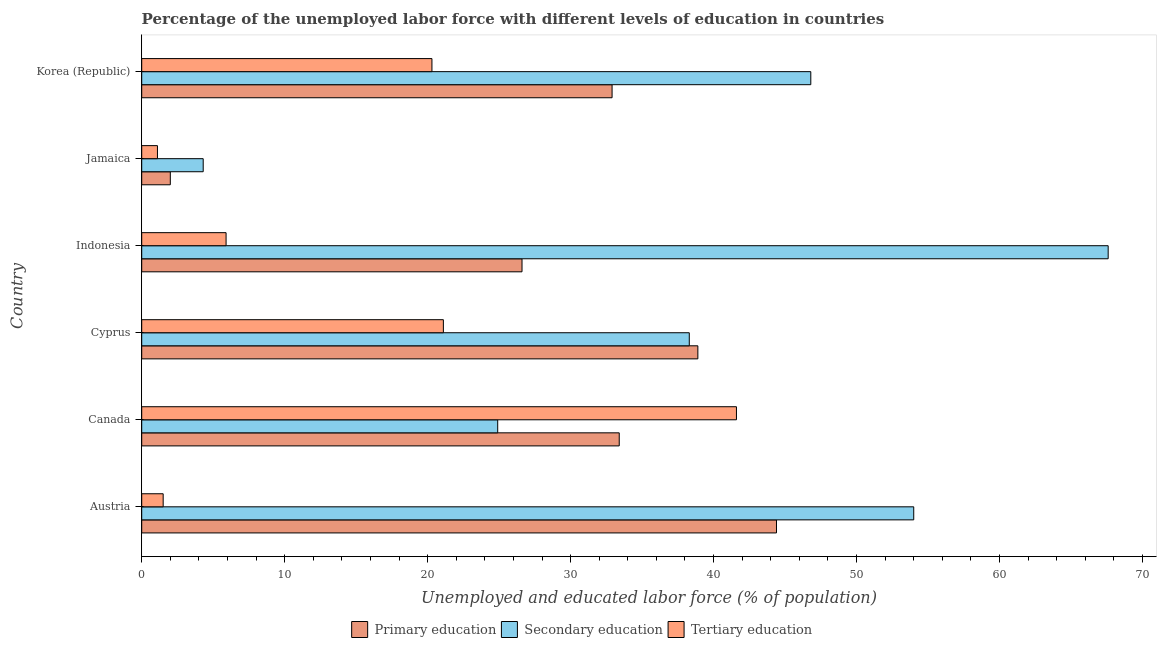How many groups of bars are there?
Your answer should be compact. 6. How many bars are there on the 1st tick from the bottom?
Provide a short and direct response. 3. What is the label of the 3rd group of bars from the top?
Provide a short and direct response. Indonesia. What is the percentage of labor force who received primary education in Indonesia?
Offer a very short reply. 26.6. Across all countries, what is the maximum percentage of labor force who received primary education?
Offer a terse response. 44.4. Across all countries, what is the minimum percentage of labor force who received secondary education?
Your answer should be very brief. 4.3. In which country was the percentage of labor force who received tertiary education maximum?
Offer a terse response. Canada. In which country was the percentage of labor force who received primary education minimum?
Provide a succinct answer. Jamaica. What is the total percentage of labor force who received tertiary education in the graph?
Provide a short and direct response. 91.5. What is the difference between the percentage of labor force who received primary education in Canada and the percentage of labor force who received tertiary education in Korea (Republic)?
Provide a short and direct response. 13.1. What is the average percentage of labor force who received secondary education per country?
Provide a short and direct response. 39.32. What is the difference between the percentage of labor force who received tertiary education and percentage of labor force who received primary education in Canada?
Provide a short and direct response. 8.2. What is the ratio of the percentage of labor force who received primary education in Austria to that in Canada?
Your answer should be very brief. 1.33. Is the difference between the percentage of labor force who received primary education in Indonesia and Korea (Republic) greater than the difference between the percentage of labor force who received tertiary education in Indonesia and Korea (Republic)?
Your answer should be compact. Yes. What is the difference between the highest and the second highest percentage of labor force who received tertiary education?
Your answer should be very brief. 20.5. What is the difference between the highest and the lowest percentage of labor force who received secondary education?
Offer a very short reply. 63.3. In how many countries, is the percentage of labor force who received secondary education greater than the average percentage of labor force who received secondary education taken over all countries?
Offer a very short reply. 3. What does the 1st bar from the bottom in Cyprus represents?
Your response must be concise. Primary education. Is it the case that in every country, the sum of the percentage of labor force who received primary education and percentage of labor force who received secondary education is greater than the percentage of labor force who received tertiary education?
Your answer should be compact. Yes. How many bars are there?
Your answer should be very brief. 18. What is the difference between two consecutive major ticks on the X-axis?
Provide a short and direct response. 10. Does the graph contain any zero values?
Offer a terse response. No. What is the title of the graph?
Offer a very short reply. Percentage of the unemployed labor force with different levels of education in countries. What is the label or title of the X-axis?
Provide a succinct answer. Unemployed and educated labor force (% of population). What is the label or title of the Y-axis?
Your answer should be compact. Country. What is the Unemployed and educated labor force (% of population) of Primary education in Austria?
Provide a short and direct response. 44.4. What is the Unemployed and educated labor force (% of population) in Secondary education in Austria?
Offer a very short reply. 54. What is the Unemployed and educated labor force (% of population) of Primary education in Canada?
Give a very brief answer. 33.4. What is the Unemployed and educated labor force (% of population) of Secondary education in Canada?
Your answer should be compact. 24.9. What is the Unemployed and educated labor force (% of population) in Tertiary education in Canada?
Keep it short and to the point. 41.6. What is the Unemployed and educated labor force (% of population) in Primary education in Cyprus?
Give a very brief answer. 38.9. What is the Unemployed and educated labor force (% of population) of Secondary education in Cyprus?
Make the answer very short. 38.3. What is the Unemployed and educated labor force (% of population) in Tertiary education in Cyprus?
Offer a very short reply. 21.1. What is the Unemployed and educated labor force (% of population) in Primary education in Indonesia?
Keep it short and to the point. 26.6. What is the Unemployed and educated labor force (% of population) of Secondary education in Indonesia?
Offer a terse response. 67.6. What is the Unemployed and educated labor force (% of population) of Tertiary education in Indonesia?
Make the answer very short. 5.9. What is the Unemployed and educated labor force (% of population) of Primary education in Jamaica?
Make the answer very short. 2. What is the Unemployed and educated labor force (% of population) of Secondary education in Jamaica?
Offer a terse response. 4.3. What is the Unemployed and educated labor force (% of population) of Tertiary education in Jamaica?
Your response must be concise. 1.1. What is the Unemployed and educated labor force (% of population) in Primary education in Korea (Republic)?
Offer a terse response. 32.9. What is the Unemployed and educated labor force (% of population) of Secondary education in Korea (Republic)?
Your answer should be compact. 46.8. What is the Unemployed and educated labor force (% of population) in Tertiary education in Korea (Republic)?
Your response must be concise. 20.3. Across all countries, what is the maximum Unemployed and educated labor force (% of population) of Primary education?
Offer a very short reply. 44.4. Across all countries, what is the maximum Unemployed and educated labor force (% of population) in Secondary education?
Provide a short and direct response. 67.6. Across all countries, what is the maximum Unemployed and educated labor force (% of population) in Tertiary education?
Your response must be concise. 41.6. Across all countries, what is the minimum Unemployed and educated labor force (% of population) of Secondary education?
Your response must be concise. 4.3. Across all countries, what is the minimum Unemployed and educated labor force (% of population) in Tertiary education?
Offer a very short reply. 1.1. What is the total Unemployed and educated labor force (% of population) in Primary education in the graph?
Make the answer very short. 178.2. What is the total Unemployed and educated labor force (% of population) in Secondary education in the graph?
Offer a very short reply. 235.9. What is the total Unemployed and educated labor force (% of population) in Tertiary education in the graph?
Make the answer very short. 91.5. What is the difference between the Unemployed and educated labor force (% of population) in Primary education in Austria and that in Canada?
Give a very brief answer. 11. What is the difference between the Unemployed and educated labor force (% of population) in Secondary education in Austria and that in Canada?
Offer a very short reply. 29.1. What is the difference between the Unemployed and educated labor force (% of population) of Tertiary education in Austria and that in Canada?
Your response must be concise. -40.1. What is the difference between the Unemployed and educated labor force (% of population) of Primary education in Austria and that in Cyprus?
Your answer should be compact. 5.5. What is the difference between the Unemployed and educated labor force (% of population) of Secondary education in Austria and that in Cyprus?
Provide a short and direct response. 15.7. What is the difference between the Unemployed and educated labor force (% of population) of Tertiary education in Austria and that in Cyprus?
Provide a succinct answer. -19.6. What is the difference between the Unemployed and educated labor force (% of population) in Primary education in Austria and that in Indonesia?
Offer a terse response. 17.8. What is the difference between the Unemployed and educated labor force (% of population) in Primary education in Austria and that in Jamaica?
Provide a short and direct response. 42.4. What is the difference between the Unemployed and educated labor force (% of population) of Secondary education in Austria and that in Jamaica?
Ensure brevity in your answer.  49.7. What is the difference between the Unemployed and educated labor force (% of population) in Primary education in Austria and that in Korea (Republic)?
Provide a short and direct response. 11.5. What is the difference between the Unemployed and educated labor force (% of population) of Tertiary education in Austria and that in Korea (Republic)?
Your answer should be compact. -18.8. What is the difference between the Unemployed and educated labor force (% of population) in Primary education in Canada and that in Cyprus?
Provide a short and direct response. -5.5. What is the difference between the Unemployed and educated labor force (% of population) of Secondary education in Canada and that in Cyprus?
Your answer should be very brief. -13.4. What is the difference between the Unemployed and educated labor force (% of population) of Tertiary education in Canada and that in Cyprus?
Provide a succinct answer. 20.5. What is the difference between the Unemployed and educated labor force (% of population) in Primary education in Canada and that in Indonesia?
Give a very brief answer. 6.8. What is the difference between the Unemployed and educated labor force (% of population) in Secondary education in Canada and that in Indonesia?
Your response must be concise. -42.7. What is the difference between the Unemployed and educated labor force (% of population) of Tertiary education in Canada and that in Indonesia?
Make the answer very short. 35.7. What is the difference between the Unemployed and educated labor force (% of population) in Primary education in Canada and that in Jamaica?
Your answer should be very brief. 31.4. What is the difference between the Unemployed and educated labor force (% of population) of Secondary education in Canada and that in Jamaica?
Provide a short and direct response. 20.6. What is the difference between the Unemployed and educated labor force (% of population) of Tertiary education in Canada and that in Jamaica?
Provide a short and direct response. 40.5. What is the difference between the Unemployed and educated labor force (% of population) of Primary education in Canada and that in Korea (Republic)?
Provide a succinct answer. 0.5. What is the difference between the Unemployed and educated labor force (% of population) in Secondary education in Canada and that in Korea (Republic)?
Provide a short and direct response. -21.9. What is the difference between the Unemployed and educated labor force (% of population) of Tertiary education in Canada and that in Korea (Republic)?
Provide a succinct answer. 21.3. What is the difference between the Unemployed and educated labor force (% of population) of Secondary education in Cyprus and that in Indonesia?
Make the answer very short. -29.3. What is the difference between the Unemployed and educated labor force (% of population) in Tertiary education in Cyprus and that in Indonesia?
Ensure brevity in your answer.  15.2. What is the difference between the Unemployed and educated labor force (% of population) of Primary education in Cyprus and that in Jamaica?
Keep it short and to the point. 36.9. What is the difference between the Unemployed and educated labor force (% of population) of Secondary education in Cyprus and that in Jamaica?
Offer a terse response. 34. What is the difference between the Unemployed and educated labor force (% of population) in Tertiary education in Cyprus and that in Jamaica?
Offer a terse response. 20. What is the difference between the Unemployed and educated labor force (% of population) of Primary education in Cyprus and that in Korea (Republic)?
Ensure brevity in your answer.  6. What is the difference between the Unemployed and educated labor force (% of population) in Secondary education in Cyprus and that in Korea (Republic)?
Make the answer very short. -8.5. What is the difference between the Unemployed and educated labor force (% of population) in Primary education in Indonesia and that in Jamaica?
Offer a terse response. 24.6. What is the difference between the Unemployed and educated labor force (% of population) in Secondary education in Indonesia and that in Jamaica?
Offer a very short reply. 63.3. What is the difference between the Unemployed and educated labor force (% of population) of Tertiary education in Indonesia and that in Jamaica?
Ensure brevity in your answer.  4.8. What is the difference between the Unemployed and educated labor force (% of population) of Secondary education in Indonesia and that in Korea (Republic)?
Your answer should be very brief. 20.8. What is the difference between the Unemployed and educated labor force (% of population) in Tertiary education in Indonesia and that in Korea (Republic)?
Your answer should be compact. -14.4. What is the difference between the Unemployed and educated labor force (% of population) of Primary education in Jamaica and that in Korea (Republic)?
Keep it short and to the point. -30.9. What is the difference between the Unemployed and educated labor force (% of population) in Secondary education in Jamaica and that in Korea (Republic)?
Give a very brief answer. -42.5. What is the difference between the Unemployed and educated labor force (% of population) of Tertiary education in Jamaica and that in Korea (Republic)?
Keep it short and to the point. -19.2. What is the difference between the Unemployed and educated labor force (% of population) in Primary education in Austria and the Unemployed and educated labor force (% of population) in Tertiary education in Cyprus?
Keep it short and to the point. 23.3. What is the difference between the Unemployed and educated labor force (% of population) of Secondary education in Austria and the Unemployed and educated labor force (% of population) of Tertiary education in Cyprus?
Your response must be concise. 32.9. What is the difference between the Unemployed and educated labor force (% of population) of Primary education in Austria and the Unemployed and educated labor force (% of population) of Secondary education in Indonesia?
Your answer should be compact. -23.2. What is the difference between the Unemployed and educated labor force (% of population) of Primary education in Austria and the Unemployed and educated labor force (% of population) of Tertiary education in Indonesia?
Your answer should be compact. 38.5. What is the difference between the Unemployed and educated labor force (% of population) in Secondary education in Austria and the Unemployed and educated labor force (% of population) in Tertiary education in Indonesia?
Ensure brevity in your answer.  48.1. What is the difference between the Unemployed and educated labor force (% of population) in Primary education in Austria and the Unemployed and educated labor force (% of population) in Secondary education in Jamaica?
Ensure brevity in your answer.  40.1. What is the difference between the Unemployed and educated labor force (% of population) of Primary education in Austria and the Unemployed and educated labor force (% of population) of Tertiary education in Jamaica?
Provide a short and direct response. 43.3. What is the difference between the Unemployed and educated labor force (% of population) in Secondary education in Austria and the Unemployed and educated labor force (% of population) in Tertiary education in Jamaica?
Give a very brief answer. 52.9. What is the difference between the Unemployed and educated labor force (% of population) of Primary education in Austria and the Unemployed and educated labor force (% of population) of Secondary education in Korea (Republic)?
Provide a succinct answer. -2.4. What is the difference between the Unemployed and educated labor force (% of population) in Primary education in Austria and the Unemployed and educated labor force (% of population) in Tertiary education in Korea (Republic)?
Offer a very short reply. 24.1. What is the difference between the Unemployed and educated labor force (% of population) of Secondary education in Austria and the Unemployed and educated labor force (% of population) of Tertiary education in Korea (Republic)?
Keep it short and to the point. 33.7. What is the difference between the Unemployed and educated labor force (% of population) of Primary education in Canada and the Unemployed and educated labor force (% of population) of Secondary education in Cyprus?
Make the answer very short. -4.9. What is the difference between the Unemployed and educated labor force (% of population) of Primary education in Canada and the Unemployed and educated labor force (% of population) of Secondary education in Indonesia?
Your answer should be compact. -34.2. What is the difference between the Unemployed and educated labor force (% of population) of Primary education in Canada and the Unemployed and educated labor force (% of population) of Tertiary education in Indonesia?
Offer a very short reply. 27.5. What is the difference between the Unemployed and educated labor force (% of population) in Primary education in Canada and the Unemployed and educated labor force (% of population) in Secondary education in Jamaica?
Provide a short and direct response. 29.1. What is the difference between the Unemployed and educated labor force (% of population) in Primary education in Canada and the Unemployed and educated labor force (% of population) in Tertiary education in Jamaica?
Make the answer very short. 32.3. What is the difference between the Unemployed and educated labor force (% of population) in Secondary education in Canada and the Unemployed and educated labor force (% of population) in Tertiary education in Jamaica?
Make the answer very short. 23.8. What is the difference between the Unemployed and educated labor force (% of population) in Primary education in Canada and the Unemployed and educated labor force (% of population) in Secondary education in Korea (Republic)?
Provide a succinct answer. -13.4. What is the difference between the Unemployed and educated labor force (% of population) of Primary education in Canada and the Unemployed and educated labor force (% of population) of Tertiary education in Korea (Republic)?
Offer a very short reply. 13.1. What is the difference between the Unemployed and educated labor force (% of population) of Primary education in Cyprus and the Unemployed and educated labor force (% of population) of Secondary education in Indonesia?
Offer a very short reply. -28.7. What is the difference between the Unemployed and educated labor force (% of population) in Primary education in Cyprus and the Unemployed and educated labor force (% of population) in Tertiary education in Indonesia?
Offer a terse response. 33. What is the difference between the Unemployed and educated labor force (% of population) of Secondary education in Cyprus and the Unemployed and educated labor force (% of population) of Tertiary education in Indonesia?
Offer a very short reply. 32.4. What is the difference between the Unemployed and educated labor force (% of population) of Primary education in Cyprus and the Unemployed and educated labor force (% of population) of Secondary education in Jamaica?
Offer a very short reply. 34.6. What is the difference between the Unemployed and educated labor force (% of population) in Primary education in Cyprus and the Unemployed and educated labor force (% of population) in Tertiary education in Jamaica?
Give a very brief answer. 37.8. What is the difference between the Unemployed and educated labor force (% of population) in Secondary education in Cyprus and the Unemployed and educated labor force (% of population) in Tertiary education in Jamaica?
Your response must be concise. 37.2. What is the difference between the Unemployed and educated labor force (% of population) of Secondary education in Cyprus and the Unemployed and educated labor force (% of population) of Tertiary education in Korea (Republic)?
Your response must be concise. 18. What is the difference between the Unemployed and educated labor force (% of population) in Primary education in Indonesia and the Unemployed and educated labor force (% of population) in Secondary education in Jamaica?
Offer a very short reply. 22.3. What is the difference between the Unemployed and educated labor force (% of population) of Secondary education in Indonesia and the Unemployed and educated labor force (% of population) of Tertiary education in Jamaica?
Make the answer very short. 66.5. What is the difference between the Unemployed and educated labor force (% of population) of Primary education in Indonesia and the Unemployed and educated labor force (% of population) of Secondary education in Korea (Republic)?
Ensure brevity in your answer.  -20.2. What is the difference between the Unemployed and educated labor force (% of population) in Primary education in Indonesia and the Unemployed and educated labor force (% of population) in Tertiary education in Korea (Republic)?
Offer a terse response. 6.3. What is the difference between the Unemployed and educated labor force (% of population) in Secondary education in Indonesia and the Unemployed and educated labor force (% of population) in Tertiary education in Korea (Republic)?
Provide a succinct answer. 47.3. What is the difference between the Unemployed and educated labor force (% of population) of Primary education in Jamaica and the Unemployed and educated labor force (% of population) of Secondary education in Korea (Republic)?
Your answer should be very brief. -44.8. What is the difference between the Unemployed and educated labor force (% of population) in Primary education in Jamaica and the Unemployed and educated labor force (% of population) in Tertiary education in Korea (Republic)?
Your response must be concise. -18.3. What is the difference between the Unemployed and educated labor force (% of population) of Secondary education in Jamaica and the Unemployed and educated labor force (% of population) of Tertiary education in Korea (Republic)?
Your answer should be very brief. -16. What is the average Unemployed and educated labor force (% of population) of Primary education per country?
Ensure brevity in your answer.  29.7. What is the average Unemployed and educated labor force (% of population) in Secondary education per country?
Your response must be concise. 39.32. What is the average Unemployed and educated labor force (% of population) in Tertiary education per country?
Ensure brevity in your answer.  15.25. What is the difference between the Unemployed and educated labor force (% of population) in Primary education and Unemployed and educated labor force (% of population) in Secondary education in Austria?
Offer a very short reply. -9.6. What is the difference between the Unemployed and educated labor force (% of population) in Primary education and Unemployed and educated labor force (% of population) in Tertiary education in Austria?
Provide a succinct answer. 42.9. What is the difference between the Unemployed and educated labor force (% of population) in Secondary education and Unemployed and educated labor force (% of population) in Tertiary education in Austria?
Your response must be concise. 52.5. What is the difference between the Unemployed and educated labor force (% of population) in Primary education and Unemployed and educated labor force (% of population) in Secondary education in Canada?
Your answer should be very brief. 8.5. What is the difference between the Unemployed and educated labor force (% of population) of Secondary education and Unemployed and educated labor force (% of population) of Tertiary education in Canada?
Give a very brief answer. -16.7. What is the difference between the Unemployed and educated labor force (% of population) in Primary education and Unemployed and educated labor force (% of population) in Secondary education in Indonesia?
Ensure brevity in your answer.  -41. What is the difference between the Unemployed and educated labor force (% of population) of Primary education and Unemployed and educated labor force (% of population) of Tertiary education in Indonesia?
Your answer should be compact. 20.7. What is the difference between the Unemployed and educated labor force (% of population) of Secondary education and Unemployed and educated labor force (% of population) of Tertiary education in Indonesia?
Give a very brief answer. 61.7. What is the difference between the Unemployed and educated labor force (% of population) in Primary education and Unemployed and educated labor force (% of population) in Secondary education in Jamaica?
Your answer should be very brief. -2.3. What is the difference between the Unemployed and educated labor force (% of population) of Secondary education and Unemployed and educated labor force (% of population) of Tertiary education in Jamaica?
Give a very brief answer. 3.2. What is the difference between the Unemployed and educated labor force (% of population) of Secondary education and Unemployed and educated labor force (% of population) of Tertiary education in Korea (Republic)?
Give a very brief answer. 26.5. What is the ratio of the Unemployed and educated labor force (% of population) in Primary education in Austria to that in Canada?
Offer a terse response. 1.33. What is the ratio of the Unemployed and educated labor force (% of population) in Secondary education in Austria to that in Canada?
Provide a short and direct response. 2.17. What is the ratio of the Unemployed and educated labor force (% of population) of Tertiary education in Austria to that in Canada?
Offer a terse response. 0.04. What is the ratio of the Unemployed and educated labor force (% of population) in Primary education in Austria to that in Cyprus?
Your response must be concise. 1.14. What is the ratio of the Unemployed and educated labor force (% of population) of Secondary education in Austria to that in Cyprus?
Give a very brief answer. 1.41. What is the ratio of the Unemployed and educated labor force (% of population) in Tertiary education in Austria to that in Cyprus?
Give a very brief answer. 0.07. What is the ratio of the Unemployed and educated labor force (% of population) of Primary education in Austria to that in Indonesia?
Keep it short and to the point. 1.67. What is the ratio of the Unemployed and educated labor force (% of population) in Secondary education in Austria to that in Indonesia?
Offer a terse response. 0.8. What is the ratio of the Unemployed and educated labor force (% of population) in Tertiary education in Austria to that in Indonesia?
Your answer should be compact. 0.25. What is the ratio of the Unemployed and educated labor force (% of population) of Secondary education in Austria to that in Jamaica?
Make the answer very short. 12.56. What is the ratio of the Unemployed and educated labor force (% of population) of Tertiary education in Austria to that in Jamaica?
Provide a short and direct response. 1.36. What is the ratio of the Unemployed and educated labor force (% of population) of Primary education in Austria to that in Korea (Republic)?
Your response must be concise. 1.35. What is the ratio of the Unemployed and educated labor force (% of population) in Secondary education in Austria to that in Korea (Republic)?
Provide a short and direct response. 1.15. What is the ratio of the Unemployed and educated labor force (% of population) of Tertiary education in Austria to that in Korea (Republic)?
Your answer should be very brief. 0.07. What is the ratio of the Unemployed and educated labor force (% of population) in Primary education in Canada to that in Cyprus?
Ensure brevity in your answer.  0.86. What is the ratio of the Unemployed and educated labor force (% of population) in Secondary education in Canada to that in Cyprus?
Give a very brief answer. 0.65. What is the ratio of the Unemployed and educated labor force (% of population) of Tertiary education in Canada to that in Cyprus?
Keep it short and to the point. 1.97. What is the ratio of the Unemployed and educated labor force (% of population) of Primary education in Canada to that in Indonesia?
Make the answer very short. 1.26. What is the ratio of the Unemployed and educated labor force (% of population) in Secondary education in Canada to that in Indonesia?
Provide a short and direct response. 0.37. What is the ratio of the Unemployed and educated labor force (% of population) in Tertiary education in Canada to that in Indonesia?
Provide a short and direct response. 7.05. What is the ratio of the Unemployed and educated labor force (% of population) in Secondary education in Canada to that in Jamaica?
Give a very brief answer. 5.79. What is the ratio of the Unemployed and educated labor force (% of population) of Tertiary education in Canada to that in Jamaica?
Your response must be concise. 37.82. What is the ratio of the Unemployed and educated labor force (% of population) in Primary education in Canada to that in Korea (Republic)?
Make the answer very short. 1.02. What is the ratio of the Unemployed and educated labor force (% of population) of Secondary education in Canada to that in Korea (Republic)?
Make the answer very short. 0.53. What is the ratio of the Unemployed and educated labor force (% of population) of Tertiary education in Canada to that in Korea (Republic)?
Ensure brevity in your answer.  2.05. What is the ratio of the Unemployed and educated labor force (% of population) of Primary education in Cyprus to that in Indonesia?
Your answer should be very brief. 1.46. What is the ratio of the Unemployed and educated labor force (% of population) in Secondary education in Cyprus to that in Indonesia?
Your response must be concise. 0.57. What is the ratio of the Unemployed and educated labor force (% of population) in Tertiary education in Cyprus to that in Indonesia?
Provide a short and direct response. 3.58. What is the ratio of the Unemployed and educated labor force (% of population) in Primary education in Cyprus to that in Jamaica?
Keep it short and to the point. 19.45. What is the ratio of the Unemployed and educated labor force (% of population) of Secondary education in Cyprus to that in Jamaica?
Offer a terse response. 8.91. What is the ratio of the Unemployed and educated labor force (% of population) in Tertiary education in Cyprus to that in Jamaica?
Offer a terse response. 19.18. What is the ratio of the Unemployed and educated labor force (% of population) of Primary education in Cyprus to that in Korea (Republic)?
Your answer should be very brief. 1.18. What is the ratio of the Unemployed and educated labor force (% of population) of Secondary education in Cyprus to that in Korea (Republic)?
Make the answer very short. 0.82. What is the ratio of the Unemployed and educated labor force (% of population) of Tertiary education in Cyprus to that in Korea (Republic)?
Give a very brief answer. 1.04. What is the ratio of the Unemployed and educated labor force (% of population) of Primary education in Indonesia to that in Jamaica?
Make the answer very short. 13.3. What is the ratio of the Unemployed and educated labor force (% of population) of Secondary education in Indonesia to that in Jamaica?
Make the answer very short. 15.72. What is the ratio of the Unemployed and educated labor force (% of population) of Tertiary education in Indonesia to that in Jamaica?
Ensure brevity in your answer.  5.36. What is the ratio of the Unemployed and educated labor force (% of population) of Primary education in Indonesia to that in Korea (Republic)?
Make the answer very short. 0.81. What is the ratio of the Unemployed and educated labor force (% of population) in Secondary education in Indonesia to that in Korea (Republic)?
Offer a terse response. 1.44. What is the ratio of the Unemployed and educated labor force (% of population) of Tertiary education in Indonesia to that in Korea (Republic)?
Provide a succinct answer. 0.29. What is the ratio of the Unemployed and educated labor force (% of population) in Primary education in Jamaica to that in Korea (Republic)?
Ensure brevity in your answer.  0.06. What is the ratio of the Unemployed and educated labor force (% of population) in Secondary education in Jamaica to that in Korea (Republic)?
Keep it short and to the point. 0.09. What is the ratio of the Unemployed and educated labor force (% of population) in Tertiary education in Jamaica to that in Korea (Republic)?
Ensure brevity in your answer.  0.05. What is the difference between the highest and the second highest Unemployed and educated labor force (% of population) of Primary education?
Provide a short and direct response. 5.5. What is the difference between the highest and the second highest Unemployed and educated labor force (% of population) in Tertiary education?
Your response must be concise. 20.5. What is the difference between the highest and the lowest Unemployed and educated labor force (% of population) of Primary education?
Make the answer very short. 42.4. What is the difference between the highest and the lowest Unemployed and educated labor force (% of population) in Secondary education?
Offer a very short reply. 63.3. What is the difference between the highest and the lowest Unemployed and educated labor force (% of population) in Tertiary education?
Offer a very short reply. 40.5. 